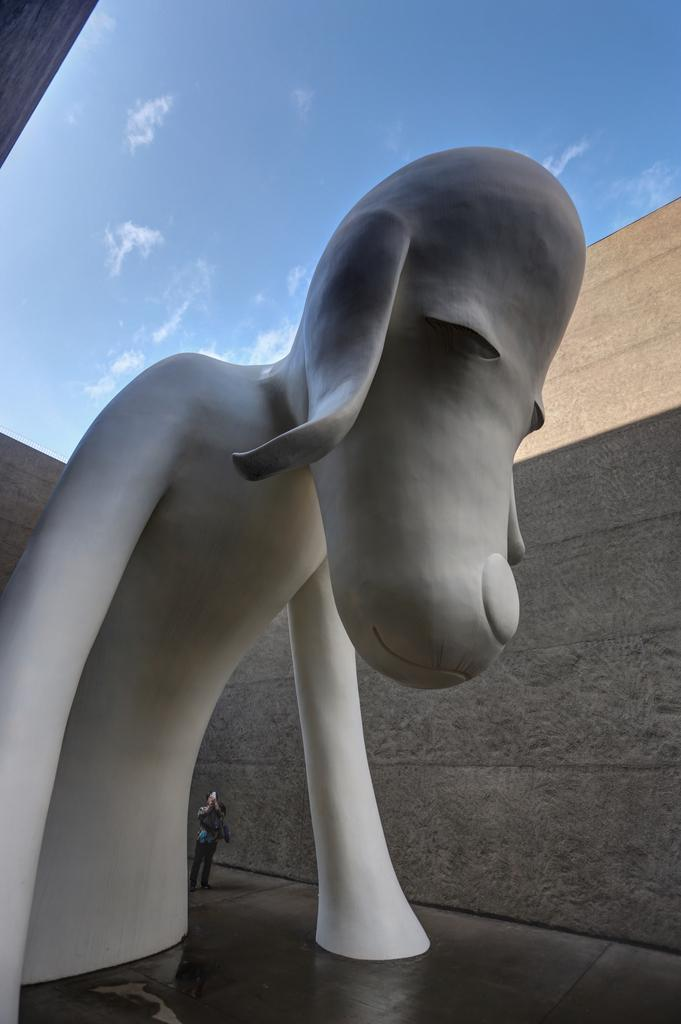What type of statue can be seen in the image? There is a statue of an animal in the image. Is there anything unusual about the statue? Yes, a person is present inside the statue. What can be seen in the background of the image? There is a wall in the image. How would you describe the weather based on the image? The sky is clear in the image, suggesting good weather. Can you see a nest in the image? There is no nest present in the image. Does the existence of the statue prove the existence of the animal it represents? The existence of the statue does not prove the existence of the animal it represents, as it could be a work of art or a representation of an extinct species. 